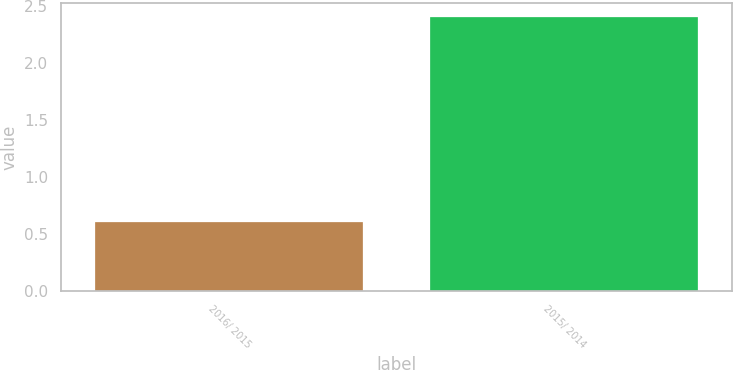<chart> <loc_0><loc_0><loc_500><loc_500><bar_chart><fcel>2016/ 2015<fcel>2015/ 2014<nl><fcel>0.6<fcel>2.4<nl></chart> 